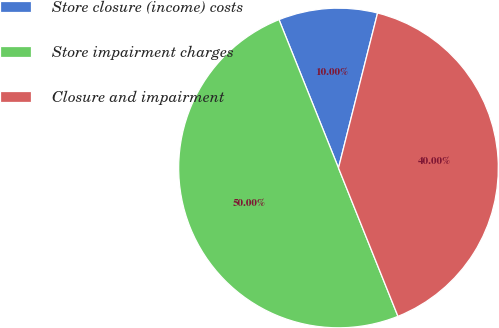Convert chart to OTSL. <chart><loc_0><loc_0><loc_500><loc_500><pie_chart><fcel>Store closure (income) costs<fcel>Store impairment charges<fcel>Closure and impairment<nl><fcel>10.0%<fcel>50.0%<fcel>40.0%<nl></chart> 